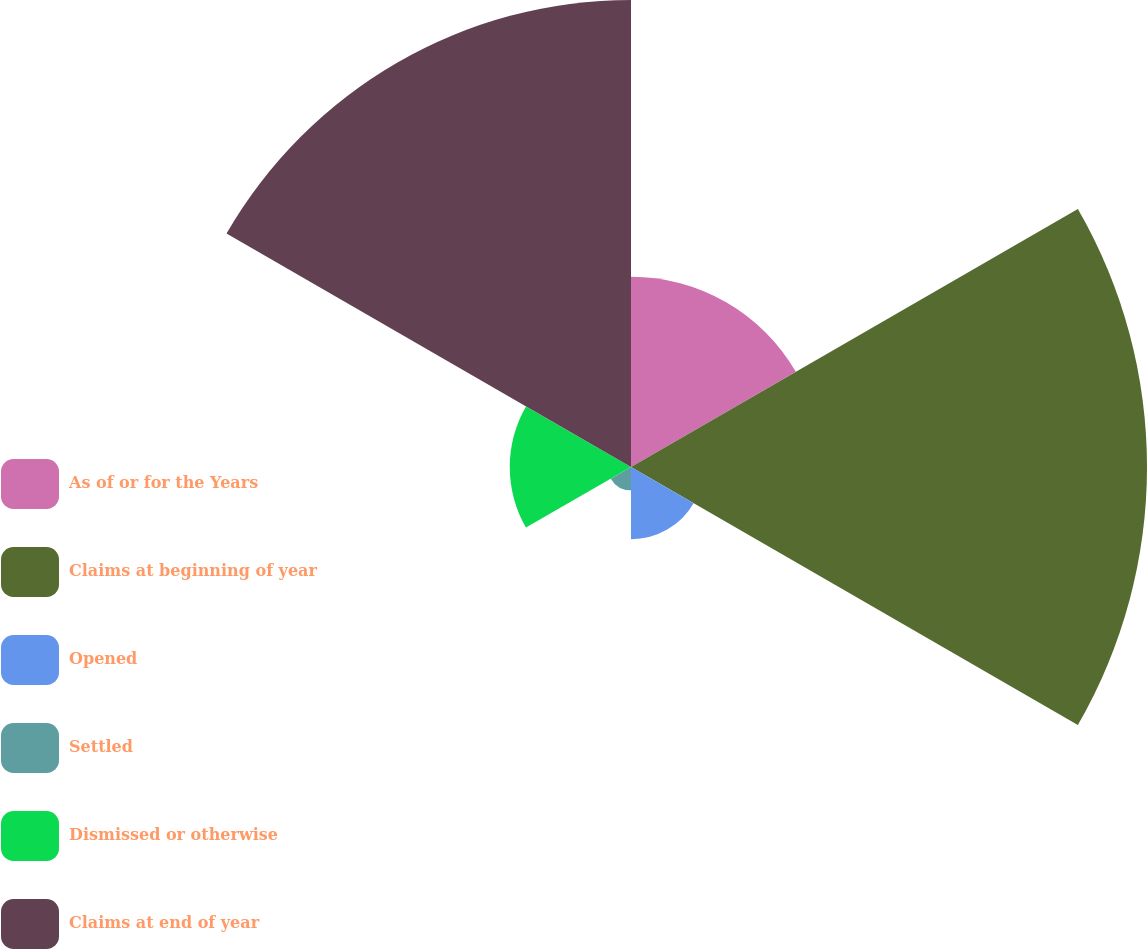Convert chart to OTSL. <chart><loc_0><loc_0><loc_500><loc_500><pie_chart><fcel>As of or for the Years<fcel>Claims at beginning of year<fcel>Opened<fcel>Settled<fcel>Dismissed or otherwise<fcel>Claims at end of year<nl><fcel>13.69%<fcel>37.11%<fcel>5.2%<fcel>1.68%<fcel>8.72%<fcel>33.59%<nl></chart> 